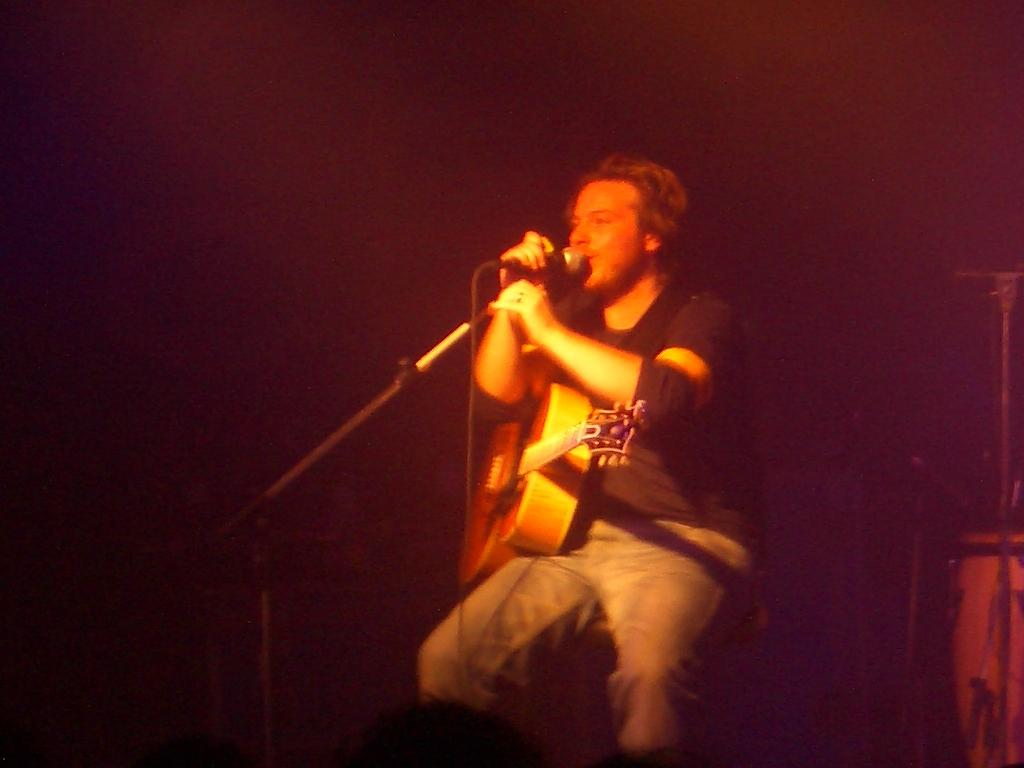What is the man in the image doing? The man is sitting on a chair and holding a mic. What else is the man holding in the image? The man is also holding a mic holder. What is the man wearing in the image? The man is wearing a guitar. What type of zinc can be seen in the image? There is no zinc present in the image. What sound can be heard in the image due to the presence of thunder? There is no thunder present in the image, so no sound can be heard. 